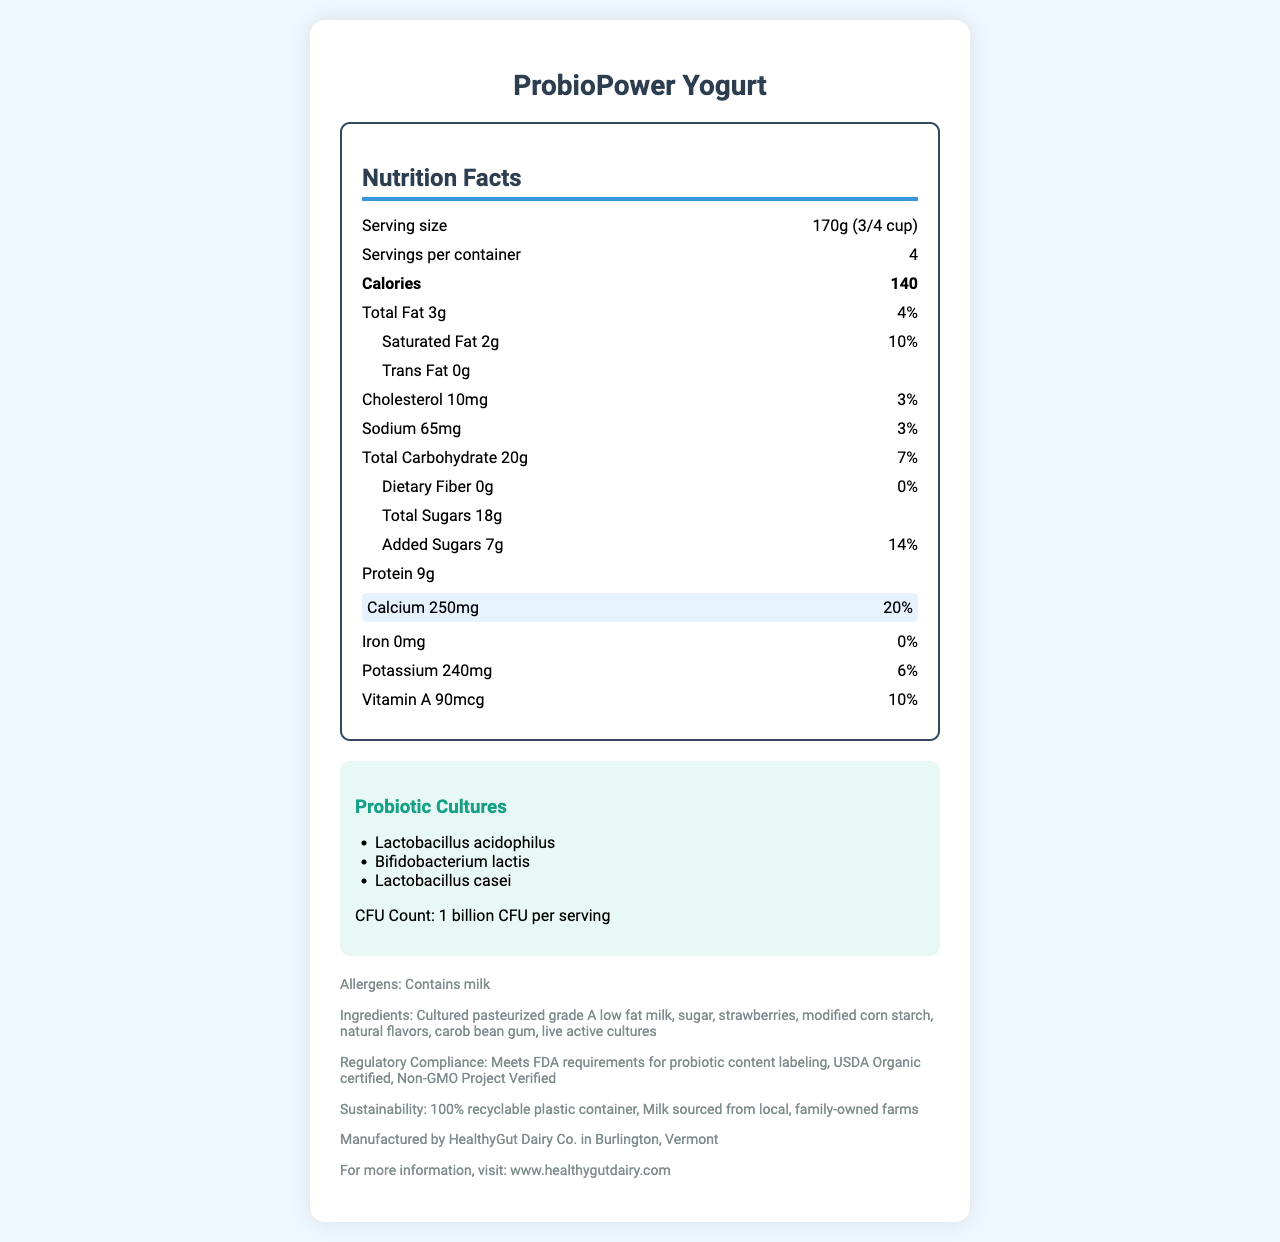what is the serving size? The serving size is specified as "170g (3/4 cup)" in the document.
Answer: 170g (3/4 cup) how many servings are in one container? The document states that there are "4 servings per container".
Answer: 4 How many calories are in one serving? The calories per serving are listed as 140 in the nutrition facts.
Answer: 140 What is the amount of total fat in one serving? The nutrition facts indicate that the total fat for one serving is 3g.
Answer: 3g Is the yogurt high in calcium? The document highlights that one serving provides 20% of the daily value for calcium, which is relatively high.
Answer: Yes which probiotic strains are included in the yogurt? A. Lactobacillus acidophilus, Bifidobacterium lactis, Streptococcus thermophilus B. Bifidobacterium lactis, Lactobacillus acidophilus, Lactobacillus casei C. Lactobacillus casei, Streptococcus thermophilus, Lactobacillus acidophilus The probiotic cultures listed are Lactobacillus acidophilus, Bifidobacterium lactis, and Lactobacillus casei.
Answer: B What percentage of daily value for sodium does one serving provide? A. 2% B. 3% C. 5% The document states that the sodium content provides 3% of the daily value per serving.
Answer: B Does the yogurt contain vitamin D? The document specifies that the amount of vitamin D is 0mcg, with a daily value of 0%.
Answer: No Summarize the main points of this nutrition facts label. This summary covers the key nutritional information, probiotic content, ingredients, and regulatory compliance as described in the document.
Answer: ProbioPower Yogurt is a probiotic yogurt with live cultures, containing Lactobacillus acidophilus, Bifidobacterium lactis, and Lactobacillus casei. Each serving is 170g, providing 140 calories, 3g total fat, and 9g protein. It is rich in calcium (20% daily value) and contains no vitamin D. Ingredients include cultured pasteurized grade A low-fat milk, sugar, and strawberries. The product meets FDA guidelines for probiotic content and is USDA Organic certified and Non-GMO Project Verified. What type of packaging is used for this yogurt? The document states that the packaging is "100% recyclable plastic container".
Answer: 100% recyclable plastic container Where is the company that makes the yogurt located? The company information section lists the location as Burlington, Vermont.
Answer: Burlington, Vermont Can the exact number of live cultures in each serving be determined? The document specifies that there are 1 billion CFU per serving.
Answer: Yes Who manufactures the ProbioPower Yogurt? The company information section states the name of the manufacturer as HealthyGut Dairy Co.
Answer: HealthyGut Dairy Co. What is the amount of added sugars in one serving? The nutrition facts indicate that the added sugars amount to 7g per serving.
Answer: 7g How much cholesterol is in one serving? The document lists the cholesterol content as 10mg per serving.
Answer: 10mg Is the yogurt USDA Organic certified? The regulatory compliance section confirms that the product is USDA Organic certified.
Answer: Yes What type of milk is used in the ingredients? The ingredients list includes "Cultured pasteurized grade A low-fat milk".
Answer: Cultured pasteurized grade A low-fat milk Does the yogurt contain any allergens? If so, which ones? The allergens section specifies that the yogurt contains milk.
Answer: Yes, it contains milk Can we determine the price of the yogurt from the document? The document does not provide any information about the price.
Answer: Cannot be determined 